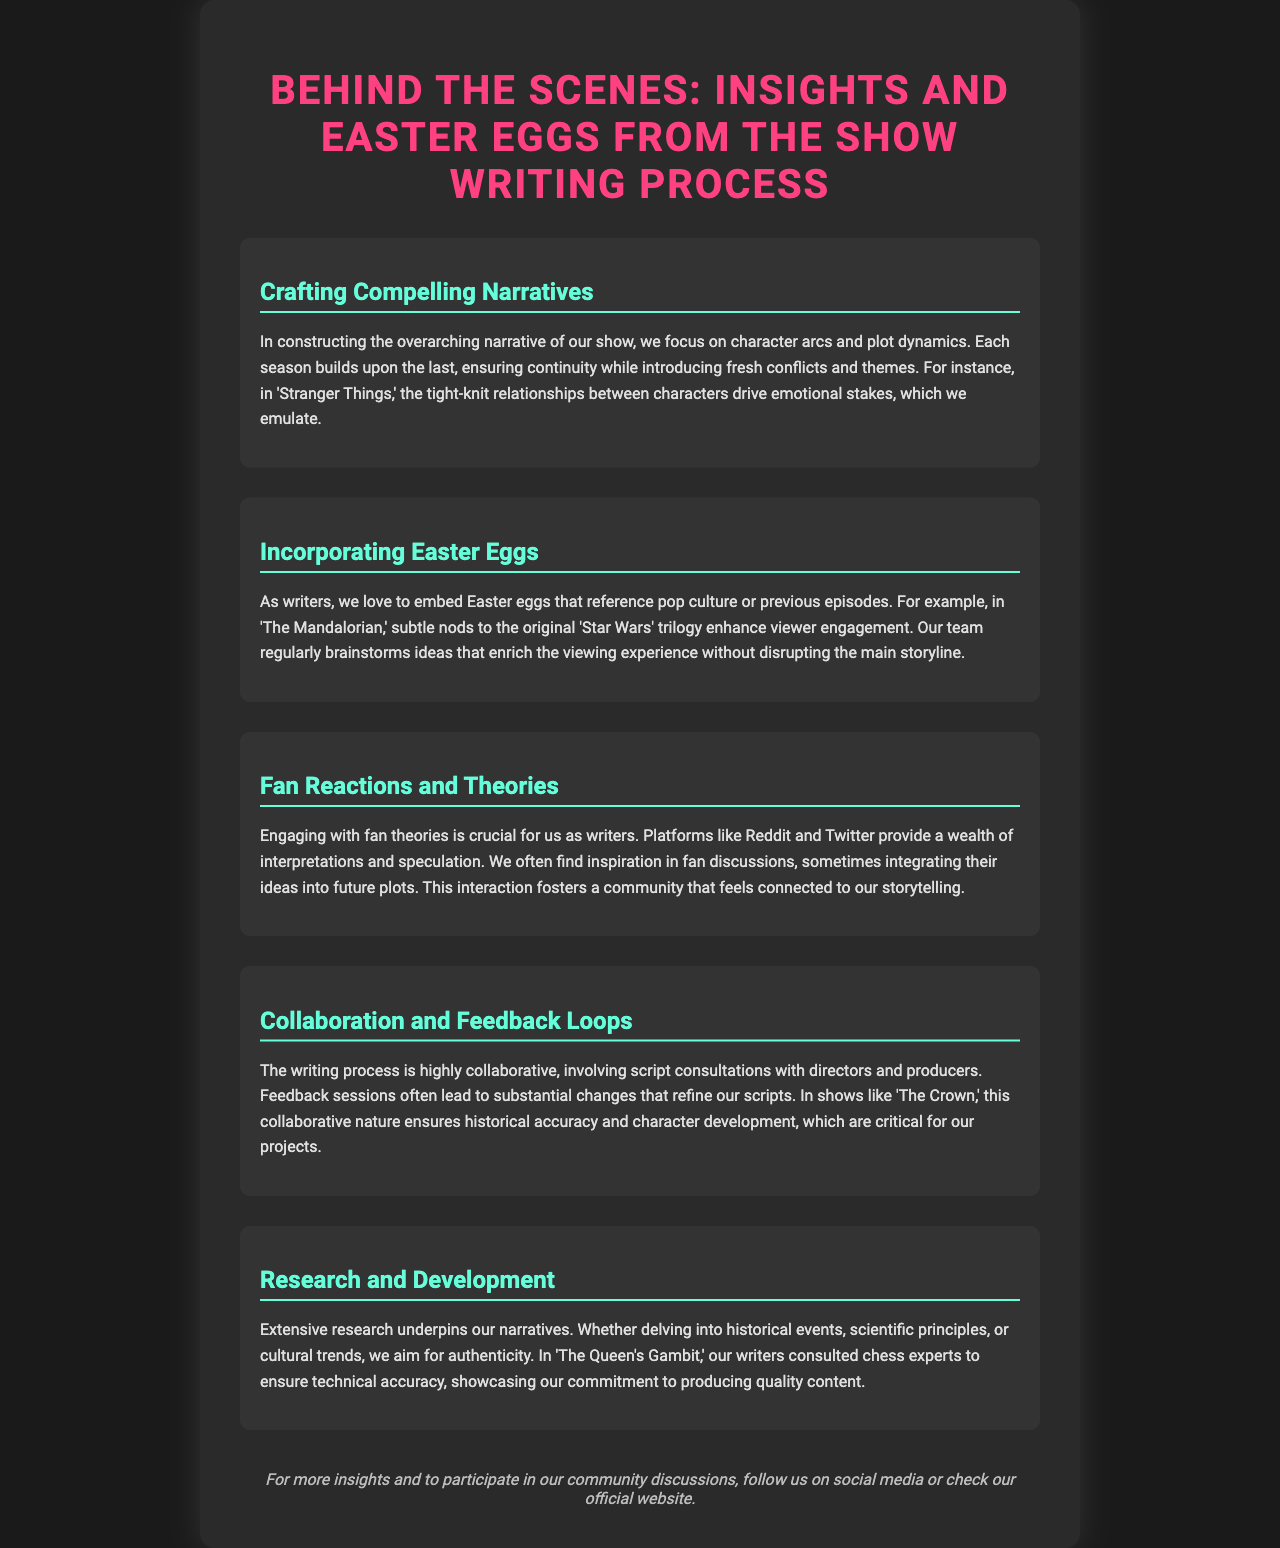what is the title of the brochure? The title is presented at the top of the document, indicating the main theme and purpose of the brochure.
Answer: Behind the Scenes: Insights and Easter Eggs from the Show Writing Process how many sections are there in the brochure? The document lists five distinct sections that cover various topics within the overall theme.
Answer: 5 which show is mentioned in the context of character arcs and emotional stakes? The specific show is cited as an example of strong character-driven narratives and emotional dynamics.
Answer: Stranger Things what do Easter eggs in the show refer to? Easter eggs are described as references that add depth to the viewing experience without interfering with the storyline.
Answer: pop culture or previous episodes which platforms do the writers use to engage with fan theories? The document identifies platforms where fan discussions take place, illustrating how writers interact with their audience.
Answer: Reddit and Twitter what is emphasized as crucial in the writing process related to collaborative efforts? The process involves working closely with other individuals in the production team to refine the scripts.
Answer: feedback sessions which historical drama is mentioned in relation to collaboration for accuracy? The example given highlights the importance of collaboration in achieving authenticity in character development and historical depiction.
Answer: The Crown what type of research is highlighted in relation to 'The Queen's Gambit'? The document notes a specific focus on ensuring the accuracy of certain elements within the storyline through expert consultations.
Answer: chess experts 